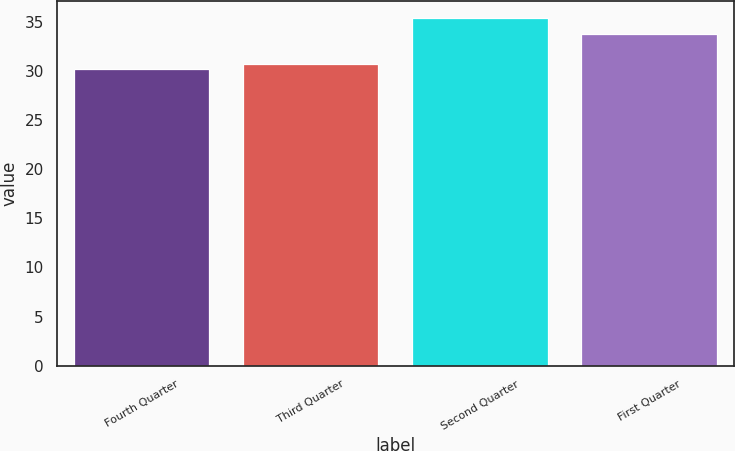<chart> <loc_0><loc_0><loc_500><loc_500><bar_chart><fcel>Fourth Quarter<fcel>Third Quarter<fcel>Second Quarter<fcel>First Quarter<nl><fcel>30.15<fcel>30.67<fcel>35.36<fcel>33.72<nl></chart> 